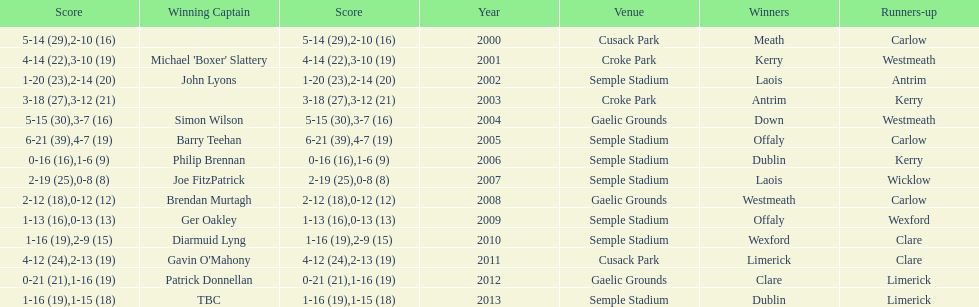Who was the winning captain the last time the competition was held at the gaelic grounds venue? Patrick Donnellan. 